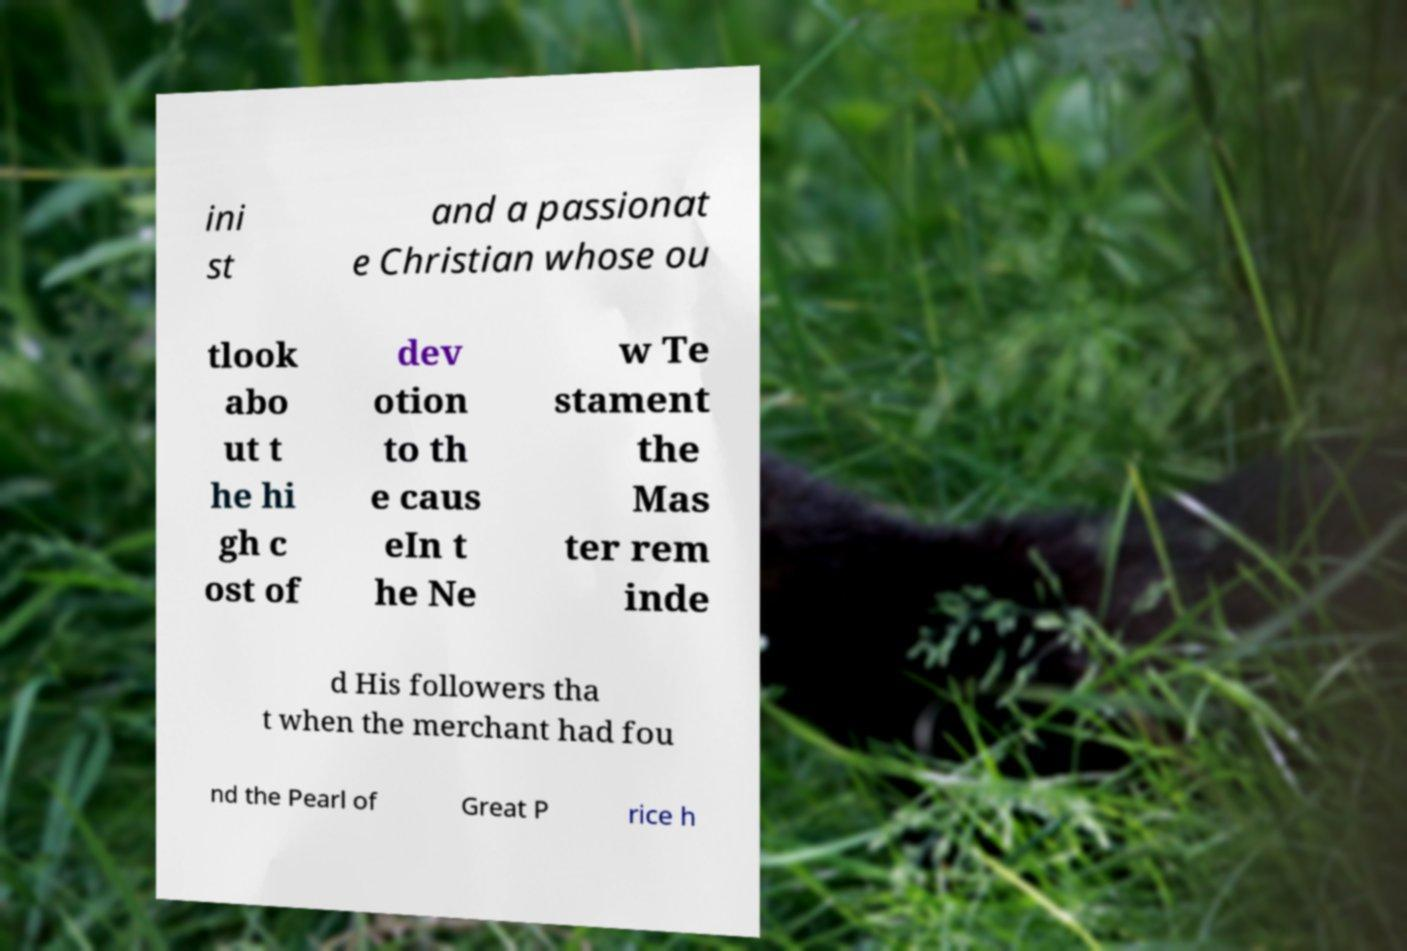Can you read and provide the text displayed in the image?This photo seems to have some interesting text. Can you extract and type it out for me? ini st and a passionat e Christian whose ou tlook abo ut t he hi gh c ost of dev otion to th e caus eIn t he Ne w Te stament the Mas ter rem inde d His followers tha t when the merchant had fou nd the Pearl of Great P rice h 